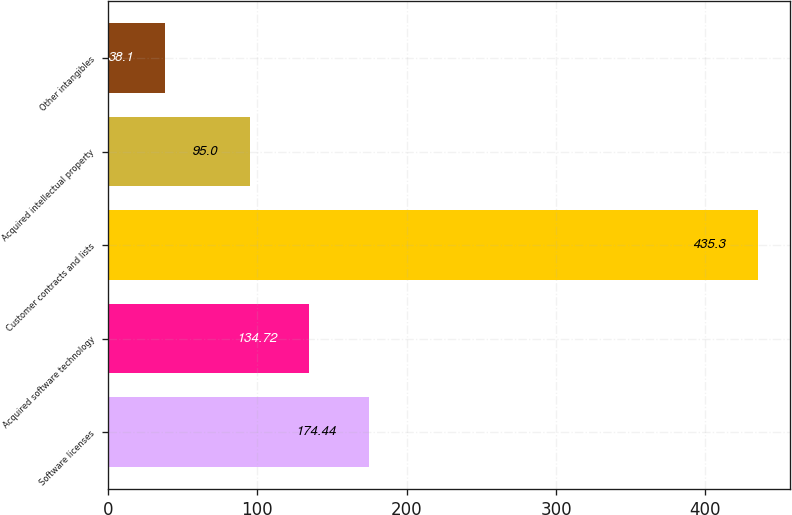<chart> <loc_0><loc_0><loc_500><loc_500><bar_chart><fcel>Software licenses<fcel>Acquired software technology<fcel>Customer contracts and lists<fcel>Acquired intellectual property<fcel>Other intangibles<nl><fcel>174.44<fcel>134.72<fcel>435.3<fcel>95<fcel>38.1<nl></chart> 